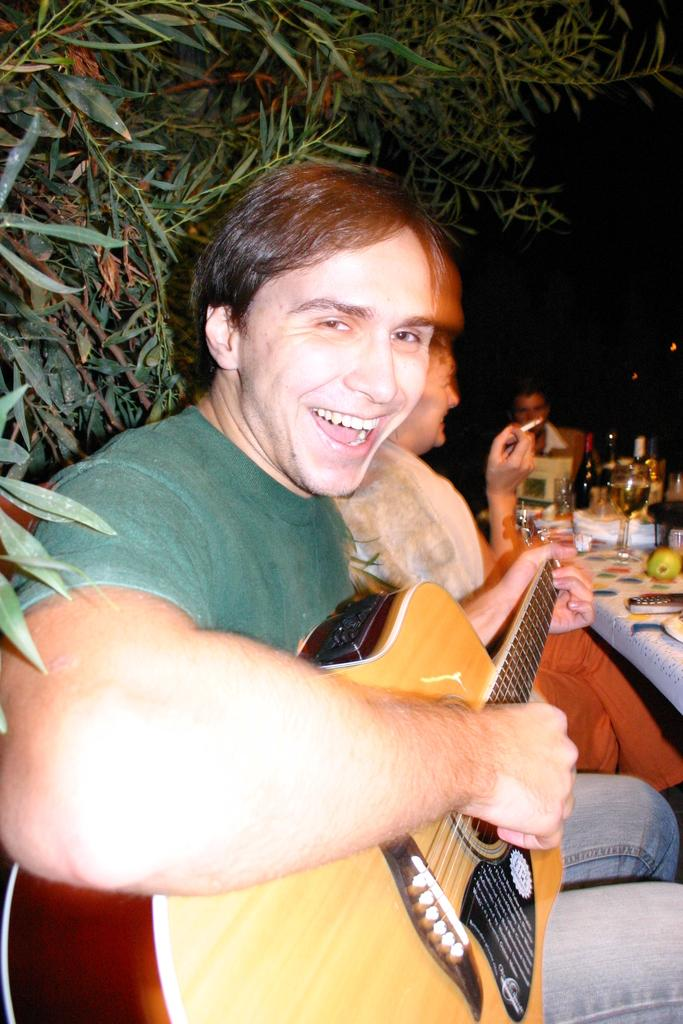What is the man in the image doing? The man is sitting in the image. What is the man holding in the image? The man is holding a guitar. What expression does the man have in the image? The man is smiling. What can be seen in the background of the image? There are trees behind the man. What thrilling event is described in the caption of the image? There is no caption present in the image, so it is not possible to answer that question. 